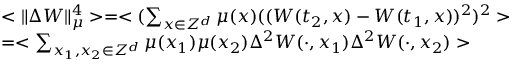<formula> <loc_0><loc_0><loc_500><loc_500>\begin{array} { r l } & { < \| \Delta W \| _ { \mu } ^ { 4 } > = < ( \sum _ { x \in Z ^ { d } } \mu ( x ) ( ( W ( t _ { 2 } , x ) - W ( t _ { 1 } , x ) ) ^ { 2 } ) ^ { 2 } > } \\ & { = < \sum _ { x _ { 1 } , x _ { 2 } \in Z ^ { d } } \mu ( x _ { 1 } ) \mu ( x _ { 2 } ) \Delta ^ { 2 } W ( \cdot , x _ { 1 } ) \Delta ^ { 2 } W ( \cdot , x _ { 2 } ) > } \end{array}</formula> 